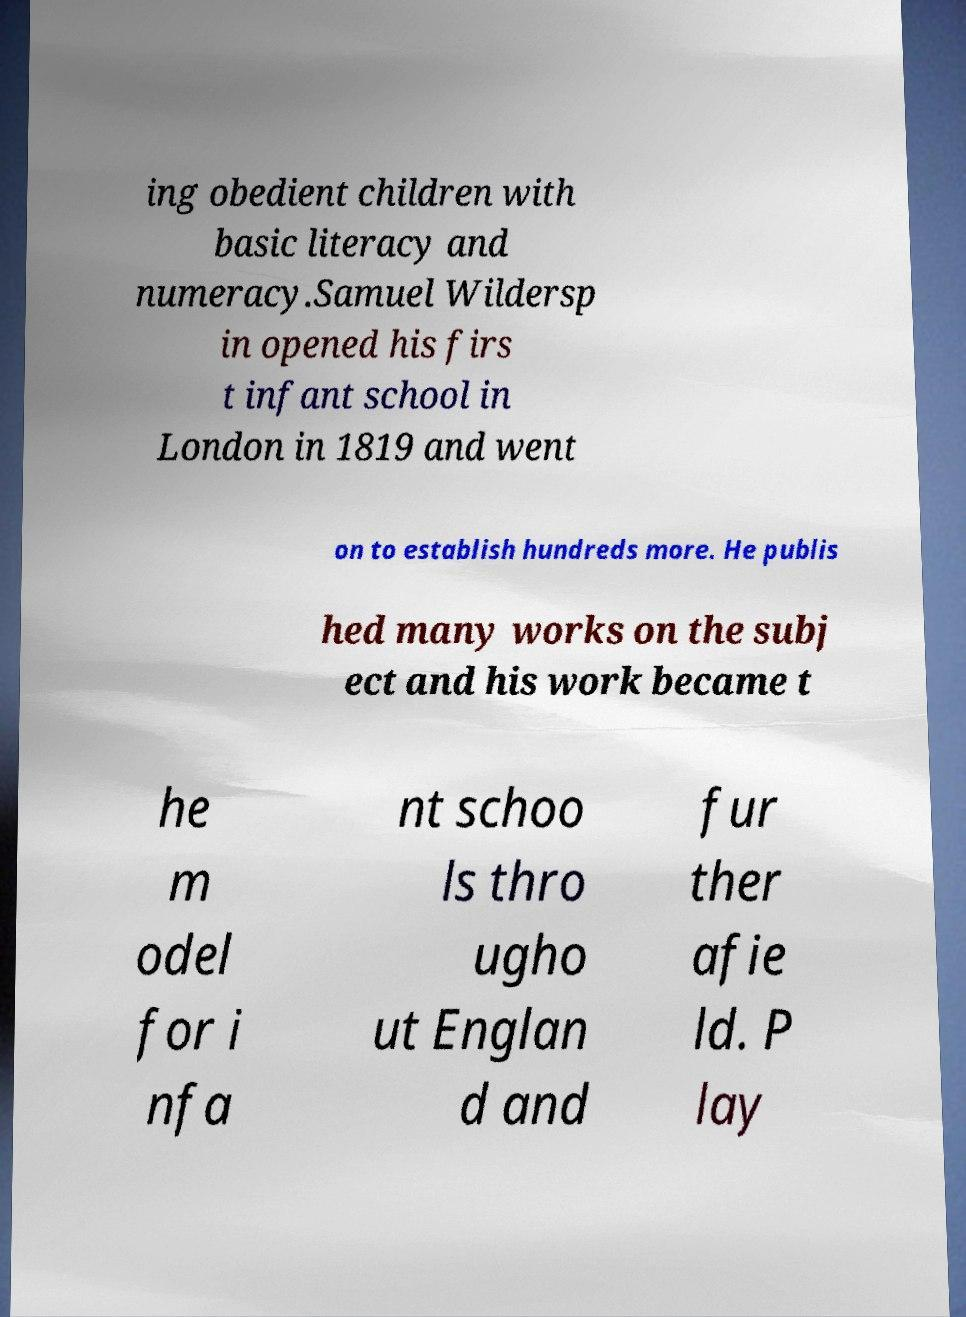Could you extract and type out the text from this image? ing obedient children with basic literacy and numeracy.Samuel Wildersp in opened his firs t infant school in London in 1819 and went on to establish hundreds more. He publis hed many works on the subj ect and his work became t he m odel for i nfa nt schoo ls thro ugho ut Englan d and fur ther afie ld. P lay 